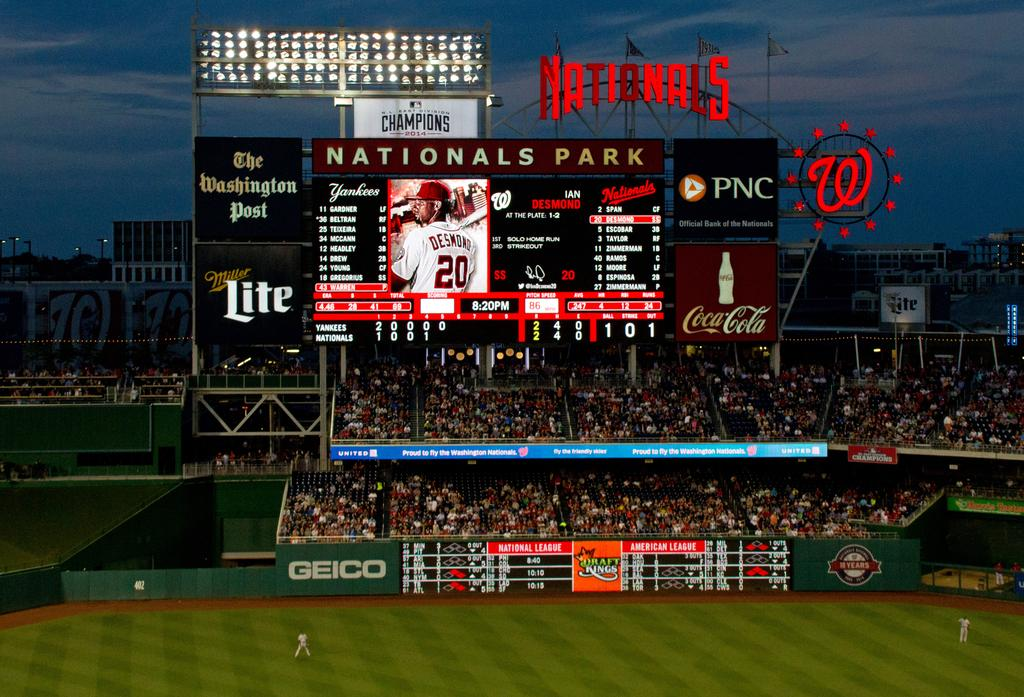<image>
Offer a succinct explanation of the picture presented. Large audience of people watching a baseball game at Nationals Park. 